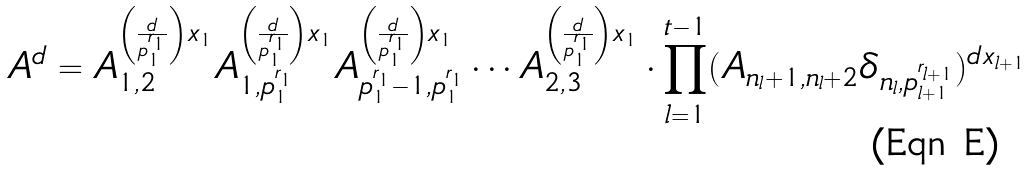<formula> <loc_0><loc_0><loc_500><loc_500>A ^ { d } = A _ { 1 , 2 } ^ { \left ( \frac { d } { p _ { 1 } ^ { r _ { 1 } } } \right ) x _ { 1 } } A _ { 1 , p _ { 1 } ^ { r _ { 1 } } } ^ { \left ( \frac { d } { p _ { 1 } ^ { r _ { 1 } } } \right ) x _ { 1 } } A _ { p _ { 1 } ^ { r _ { 1 } } - 1 , p _ { 1 } ^ { r _ { 1 } } } ^ { \left ( \frac { d } { p _ { 1 } ^ { r _ { 1 } } } \right ) x _ { 1 } } \cdots A _ { 2 , 3 } ^ { \left ( \frac { d } { p _ { 1 } ^ { r _ { 1 } } } \right ) x _ { 1 } } \cdot \prod _ { l = 1 } ^ { t - 1 } ( A _ { n _ { l } + 1 , n _ { l } + 2 } \delta _ { n _ { l } , p _ { l + 1 } ^ { r _ { l + 1 } } } ) ^ { d x _ { l + 1 } }</formula> 